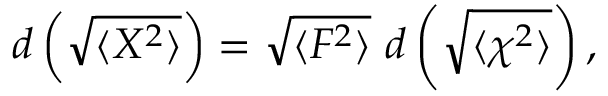<formula> <loc_0><loc_0><loc_500><loc_500>d \left ( \sqrt { \langle X ^ { 2 } \rangle } \right ) = \sqrt { \langle F ^ { 2 } \rangle } d \left ( \sqrt { \langle \chi ^ { 2 } \rangle } \right ) ,</formula> 